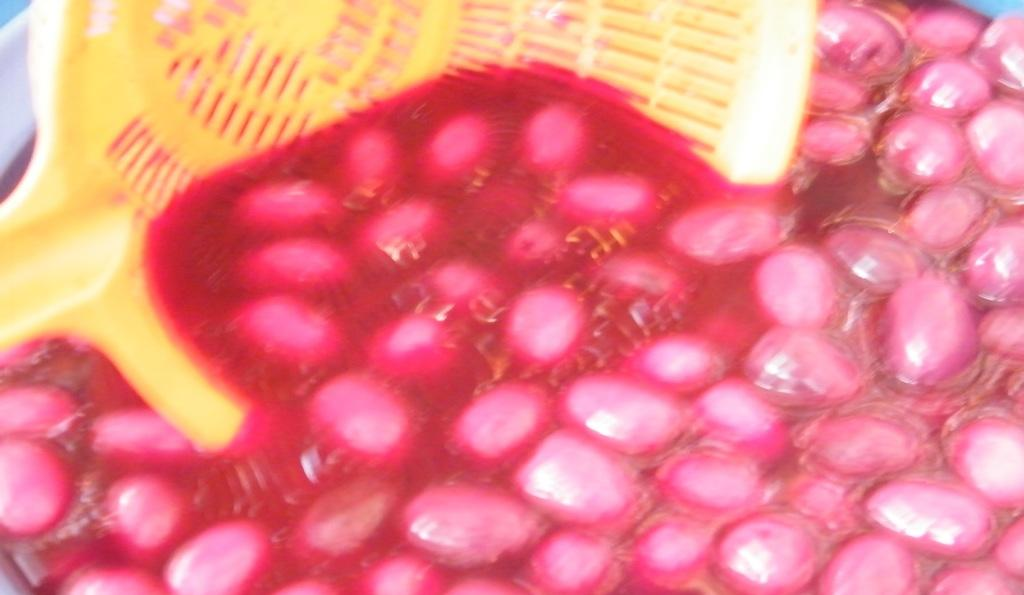What is the color of the food item in the image? The food item in the image is pink-colored. What is placed on the pink-colored food item? There is a yellow-colored thing on the food item. Can you see a gate in the image? There is no gate present in the image. Is the food item under attack in the image? There is no indication of an attack in the image; it simply shows a pink-colored food item with a yellow-colored thing on it. 